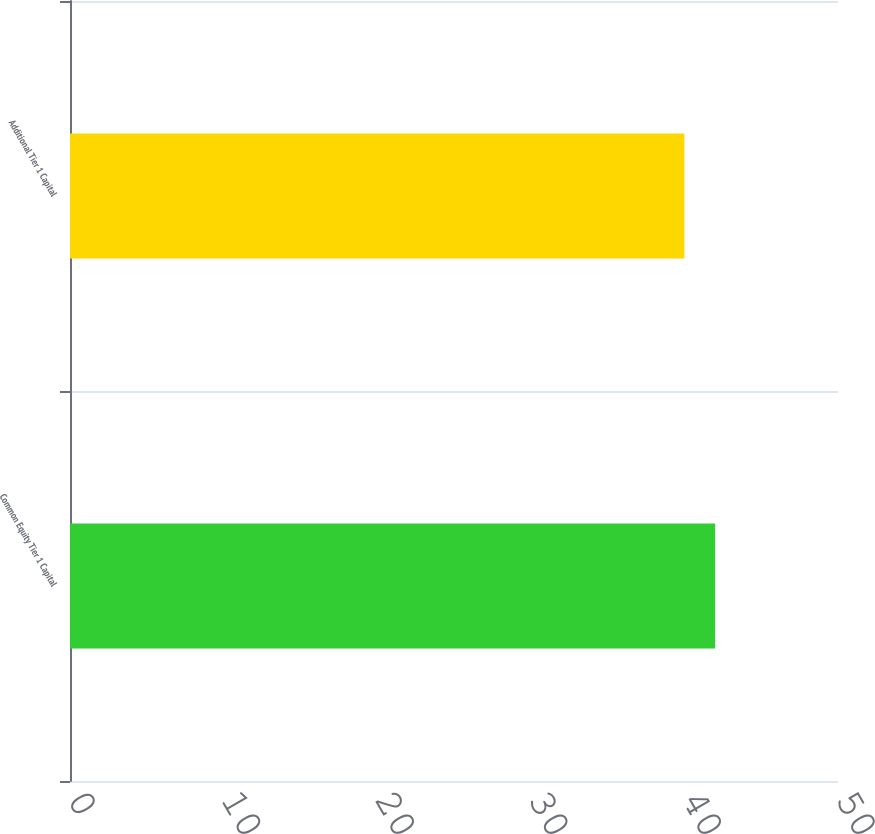Convert chart. <chart><loc_0><loc_0><loc_500><loc_500><bar_chart><fcel>Common Equity Tier 1 Capital<fcel>Additional Tier 1 Capital<nl><fcel>42<fcel>40<nl></chart> 